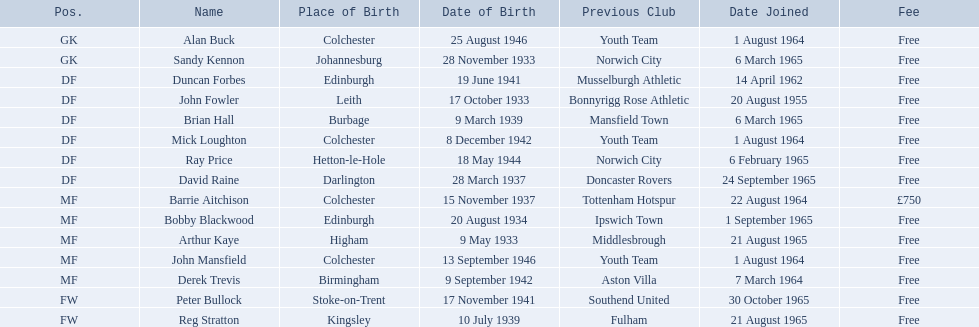Who are all the members? Alan Buck, Sandy Kennon, Duncan Forbes, John Fowler, Brian Hall, Mick Loughton, Ray Price, David Raine, Barrie Aitchison, Bobby Blackwood, Arthur Kaye, John Mansfield, Derek Trevis, Peter Bullock, Reg Stratton. What dates did the members join on? 1 August 1964, 6 March 1965, 14 April 1962, 20 August 1955, 6 March 1965, 1 August 1964, 6 February 1965, 24 September 1965, 22 August 1964, 1 September 1965, 21 August 1965, 1 August 1964, 7 March 1964, 30 October 1965, 21 August 1965. Who is the earliest member who joined? John Fowler. What is the date of the first person who joined? 20 August 1955. 